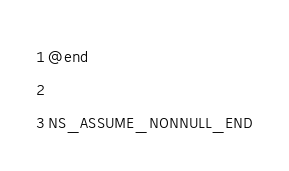<code> <loc_0><loc_0><loc_500><loc_500><_C_>
@end

NS_ASSUME_NONNULL_END
</code> 